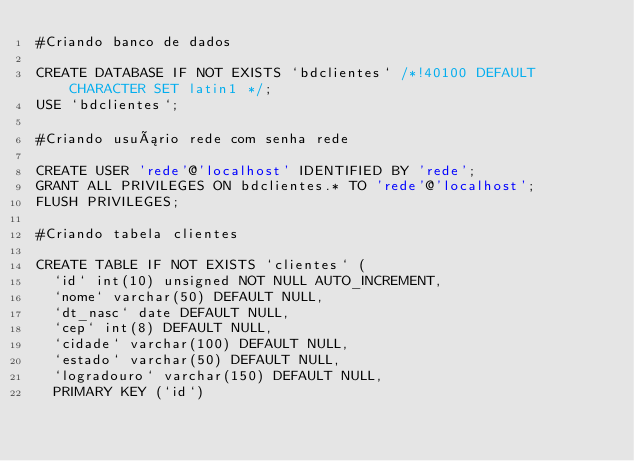<code> <loc_0><loc_0><loc_500><loc_500><_SQL_>#Criando banco de dados

CREATE DATABASE IF NOT EXISTS `bdclientes` /*!40100 DEFAULT CHARACTER SET latin1 */;
USE `bdclientes`;

#Criando usuário rede com senha rede

CREATE USER 'rede'@'localhost' IDENTIFIED BY 'rede';
GRANT ALL PRIVILEGES ON bdclientes.* TO 'rede'@'localhost';
FLUSH PRIVILEGES;

#Criando tabela clientes 

CREATE TABLE IF NOT EXISTS `clientes` (
  `id` int(10) unsigned NOT NULL AUTO_INCREMENT,
  `nome` varchar(50) DEFAULT NULL,
  `dt_nasc` date DEFAULT NULL,
  `cep` int(8) DEFAULT NULL,
  `cidade` varchar(100) DEFAULT NULL,
  `estado` varchar(50) DEFAULT NULL,
  `logradouro` varchar(150) DEFAULT NULL,
  PRIMARY KEY (`id`)</code> 